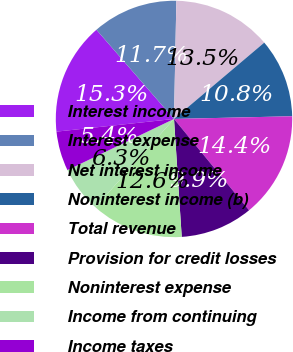<chart> <loc_0><loc_0><loc_500><loc_500><pie_chart><fcel>Interest income<fcel>Interest expense<fcel>Net interest income<fcel>Noninterest income (b)<fcel>Total revenue<fcel>Provision for credit losses<fcel>Noninterest expense<fcel>Income from continuing<fcel>Income taxes<nl><fcel>15.32%<fcel>11.71%<fcel>13.51%<fcel>10.81%<fcel>14.41%<fcel>9.91%<fcel>12.61%<fcel>6.31%<fcel>5.41%<nl></chart> 